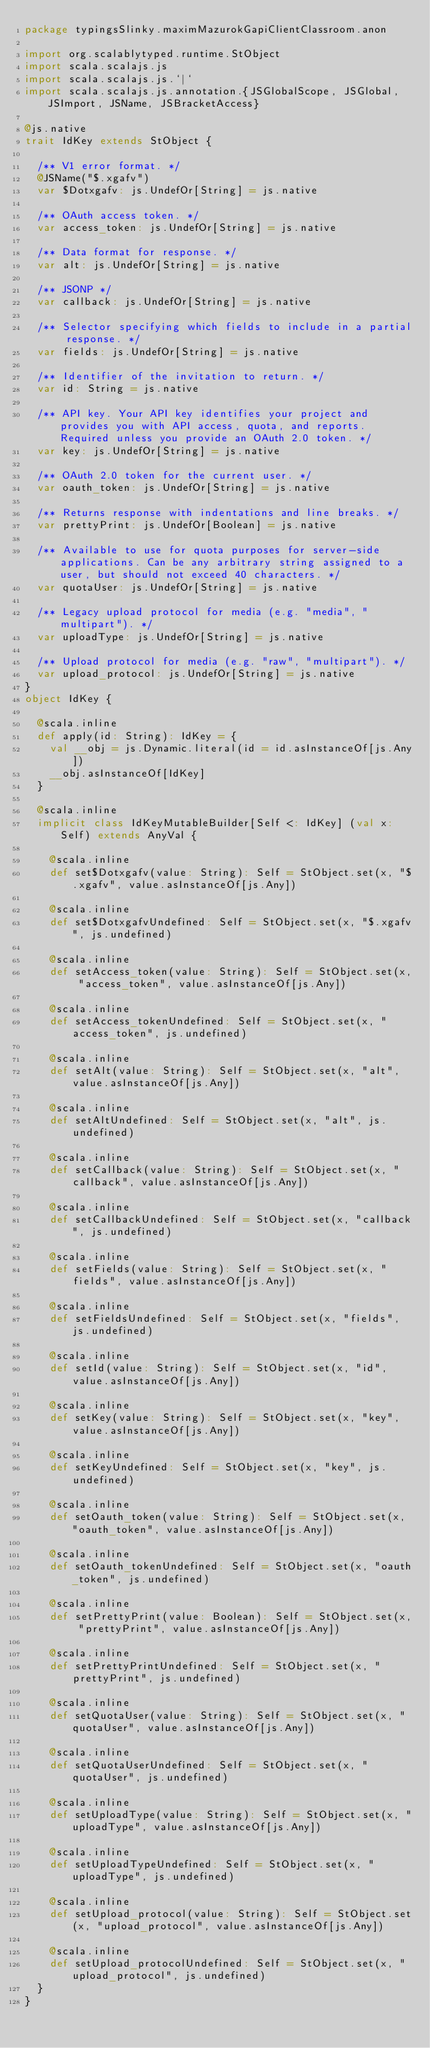Convert code to text. <code><loc_0><loc_0><loc_500><loc_500><_Scala_>package typingsSlinky.maximMazurokGapiClientClassroom.anon

import org.scalablytyped.runtime.StObject
import scala.scalajs.js
import scala.scalajs.js.`|`
import scala.scalajs.js.annotation.{JSGlobalScope, JSGlobal, JSImport, JSName, JSBracketAccess}

@js.native
trait IdKey extends StObject {
  
  /** V1 error format. */
  @JSName("$.xgafv")
  var $Dotxgafv: js.UndefOr[String] = js.native
  
  /** OAuth access token. */
  var access_token: js.UndefOr[String] = js.native
  
  /** Data format for response. */
  var alt: js.UndefOr[String] = js.native
  
  /** JSONP */
  var callback: js.UndefOr[String] = js.native
  
  /** Selector specifying which fields to include in a partial response. */
  var fields: js.UndefOr[String] = js.native
  
  /** Identifier of the invitation to return. */
  var id: String = js.native
  
  /** API key. Your API key identifies your project and provides you with API access, quota, and reports. Required unless you provide an OAuth 2.0 token. */
  var key: js.UndefOr[String] = js.native
  
  /** OAuth 2.0 token for the current user. */
  var oauth_token: js.UndefOr[String] = js.native
  
  /** Returns response with indentations and line breaks. */
  var prettyPrint: js.UndefOr[Boolean] = js.native
  
  /** Available to use for quota purposes for server-side applications. Can be any arbitrary string assigned to a user, but should not exceed 40 characters. */
  var quotaUser: js.UndefOr[String] = js.native
  
  /** Legacy upload protocol for media (e.g. "media", "multipart"). */
  var uploadType: js.UndefOr[String] = js.native
  
  /** Upload protocol for media (e.g. "raw", "multipart"). */
  var upload_protocol: js.UndefOr[String] = js.native
}
object IdKey {
  
  @scala.inline
  def apply(id: String): IdKey = {
    val __obj = js.Dynamic.literal(id = id.asInstanceOf[js.Any])
    __obj.asInstanceOf[IdKey]
  }
  
  @scala.inline
  implicit class IdKeyMutableBuilder[Self <: IdKey] (val x: Self) extends AnyVal {
    
    @scala.inline
    def set$Dotxgafv(value: String): Self = StObject.set(x, "$.xgafv", value.asInstanceOf[js.Any])
    
    @scala.inline
    def set$DotxgafvUndefined: Self = StObject.set(x, "$.xgafv", js.undefined)
    
    @scala.inline
    def setAccess_token(value: String): Self = StObject.set(x, "access_token", value.asInstanceOf[js.Any])
    
    @scala.inline
    def setAccess_tokenUndefined: Self = StObject.set(x, "access_token", js.undefined)
    
    @scala.inline
    def setAlt(value: String): Self = StObject.set(x, "alt", value.asInstanceOf[js.Any])
    
    @scala.inline
    def setAltUndefined: Self = StObject.set(x, "alt", js.undefined)
    
    @scala.inline
    def setCallback(value: String): Self = StObject.set(x, "callback", value.asInstanceOf[js.Any])
    
    @scala.inline
    def setCallbackUndefined: Self = StObject.set(x, "callback", js.undefined)
    
    @scala.inline
    def setFields(value: String): Self = StObject.set(x, "fields", value.asInstanceOf[js.Any])
    
    @scala.inline
    def setFieldsUndefined: Self = StObject.set(x, "fields", js.undefined)
    
    @scala.inline
    def setId(value: String): Self = StObject.set(x, "id", value.asInstanceOf[js.Any])
    
    @scala.inline
    def setKey(value: String): Self = StObject.set(x, "key", value.asInstanceOf[js.Any])
    
    @scala.inline
    def setKeyUndefined: Self = StObject.set(x, "key", js.undefined)
    
    @scala.inline
    def setOauth_token(value: String): Self = StObject.set(x, "oauth_token", value.asInstanceOf[js.Any])
    
    @scala.inline
    def setOauth_tokenUndefined: Self = StObject.set(x, "oauth_token", js.undefined)
    
    @scala.inline
    def setPrettyPrint(value: Boolean): Self = StObject.set(x, "prettyPrint", value.asInstanceOf[js.Any])
    
    @scala.inline
    def setPrettyPrintUndefined: Self = StObject.set(x, "prettyPrint", js.undefined)
    
    @scala.inline
    def setQuotaUser(value: String): Self = StObject.set(x, "quotaUser", value.asInstanceOf[js.Any])
    
    @scala.inline
    def setQuotaUserUndefined: Self = StObject.set(x, "quotaUser", js.undefined)
    
    @scala.inline
    def setUploadType(value: String): Self = StObject.set(x, "uploadType", value.asInstanceOf[js.Any])
    
    @scala.inline
    def setUploadTypeUndefined: Self = StObject.set(x, "uploadType", js.undefined)
    
    @scala.inline
    def setUpload_protocol(value: String): Self = StObject.set(x, "upload_protocol", value.asInstanceOf[js.Any])
    
    @scala.inline
    def setUpload_protocolUndefined: Self = StObject.set(x, "upload_protocol", js.undefined)
  }
}
</code> 